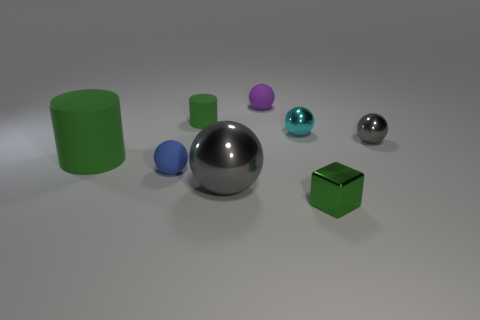Subtract all purple balls. How many balls are left? 4 Subtract all cyan metallic balls. How many balls are left? 4 Subtract 2 spheres. How many spheres are left? 3 Add 1 blue spheres. How many objects exist? 9 Subtract all yellow spheres. Subtract all yellow cylinders. How many spheres are left? 5 Subtract all cylinders. How many objects are left? 6 Add 2 matte cylinders. How many matte cylinders exist? 4 Subtract 0 cyan blocks. How many objects are left? 8 Subtract all small blue metal things. Subtract all small green shiny cubes. How many objects are left? 7 Add 8 cubes. How many cubes are left? 9 